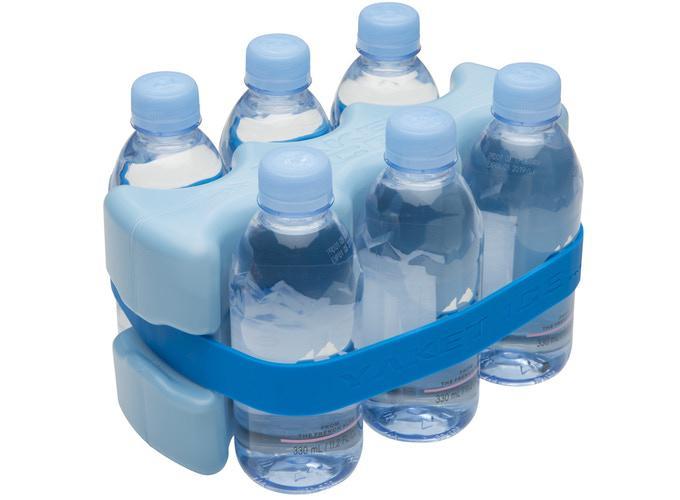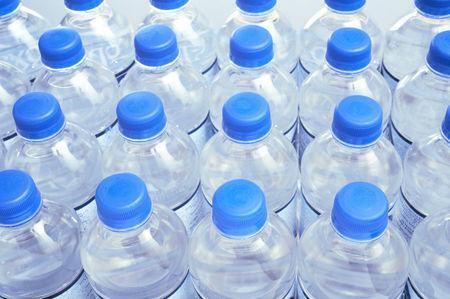The first image is the image on the left, the second image is the image on the right. For the images shown, is this caption "In 1 of the images, the bottles have large rectangular reflections." true? Answer yes or no. No. 